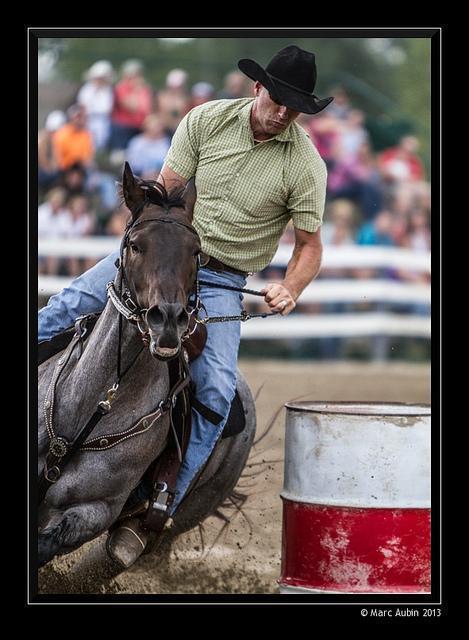What type activity does the man here take part in?
Indicate the correct response by choosing from the four available options to answer the question.
Options: Barrel racing, bull riding, car race, roping. Barrel racing. 